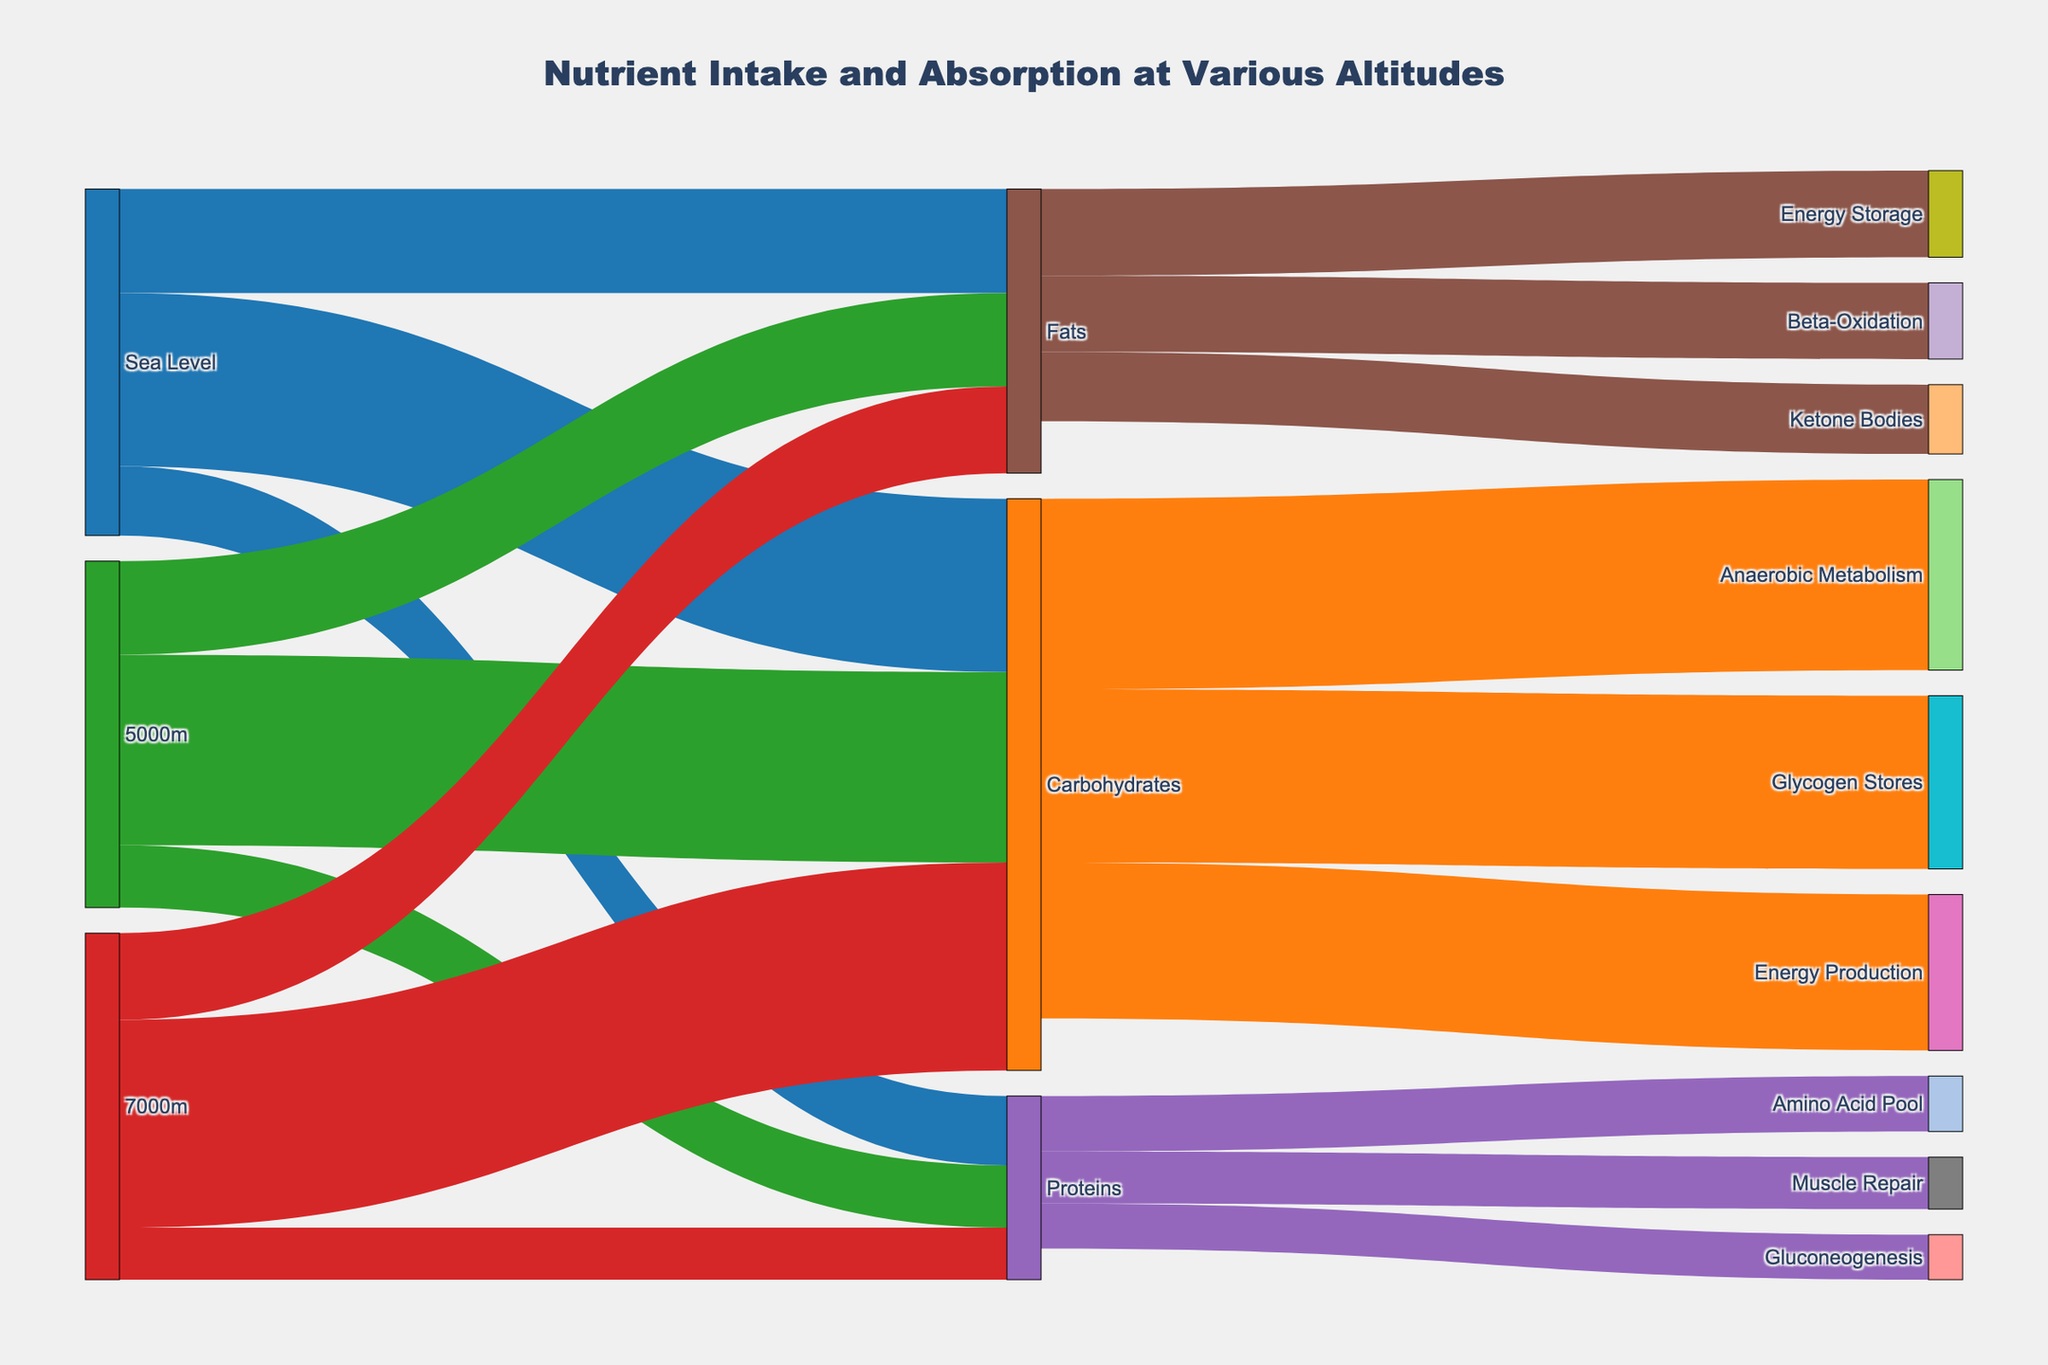What is the title of the plot? The title is typically located at the top center of the plot. It gives an overview of the figure's purpose.
Answer: Nutrient Intake and Absorption at Various Altitudes What are the macronutrient sources at sea level? Look for the nodes linked directly from the "Sea Level" node. These represent the macronutrient sources.
Answer: Carbohydrates, Proteins, Fats How many total macronutrients are utilized at 5000m? Sum the values of all macronutrients starting from "5000m." From the diagram, this includes Carbohydrates (550), Proteins (180), and Fats (270). Calculate the total.
Answer: 1000 What is the difference in carbohydrate utilization between 7000m and sea level? Compare the "Carbohydrates" values from "7000m" and "Sea Level". At 7000m it is 600, and at sea level, it is 500. Subtract the sea level value from the 7000m value: 600 - 500.
Answer: 100 How does the protein allocation to muscle repair at sea level compare to its allocation for gluconeogenesis at 7000m? Find the values linked to "Muscle Repair" from sea level and "Gluconeogenesis" from 7000m. Muscle Repair is 150 and Gluconeogenesis is 130. Compare these values.
Answer: Muscle Repair (150) is larger than Gluconeogenesis (130) What happens to fats in the body at 5000m compared to 7000m? Look at the target nodes for fats from "5000m" and "7000m." At 5000m, fats are converted to "Ketone Bodies" (200), and at 7000m, they are involved in "Beta-Oxidation" (220).
Answer: Fats convert to more Beta-Oxidation at 7000m (220) compared to Ketone Bodies at 5000m (200) What percentage of carbohydrates at sea level is used for energy production? The value for energy production from carbohydrates at sea level is 450 out of a total 500. The percentage can be calculated as (450/500) * 100.
Answer: 90% Which nutrient allocation decreases the most between sea level and 7000m? Compare the values of Carbohydrates, Proteins, and Fats from sea level and 7000m. Calculate the differences: Carbohydrates (600 - 500), Proteins (150 - 200), Fats (250 - 300). Identify the largest decrease.
Answer: Proteins (50 decrease) Which altitude shows the highest protein intake for muscle repair? Check the value allocated to "Muscle Repair" from various altitudes. Only sea level links to muscle repair, which has a value of 150.
Answer: Sea Level 